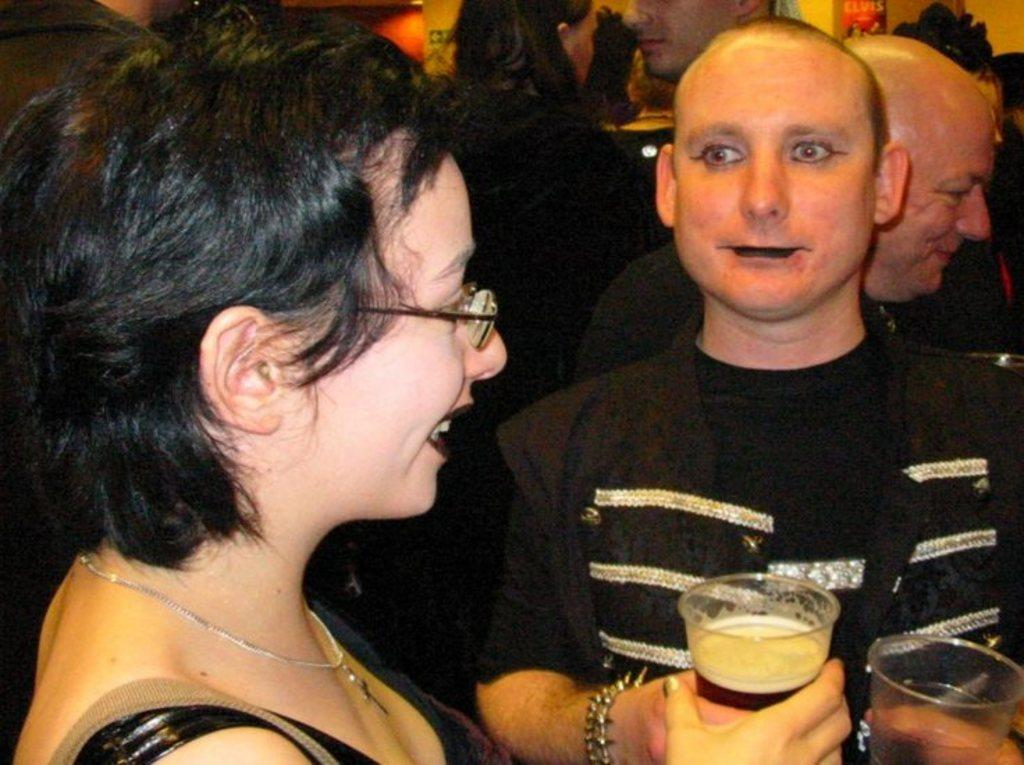Who is present in the image? There is a woman and a man in the image. What is the woman holding in her hand? The woman is holding a wine glass in her hand. What is the man doing in the image? The man is standing and looking at the woman. What type of grain can be seen growing in the image? There is no grain present in the image; it features a woman holding a wine glass and a man standing and looking at her. 